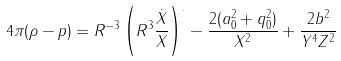<formula> <loc_0><loc_0><loc_500><loc_500>4 \pi ( \rho - p ) = R ^ { - 3 } \left ( R ^ { 3 } \frac { \dot { X } } { X } \right ) ^ { . } - \frac { 2 ( a _ { 0 } ^ { 2 } + q _ { 0 } ^ { 2 } ) } { X ^ { 2 } } + \frac { 2 b ^ { 2 } } { Y ^ { 4 } Z ^ { 2 } }</formula> 